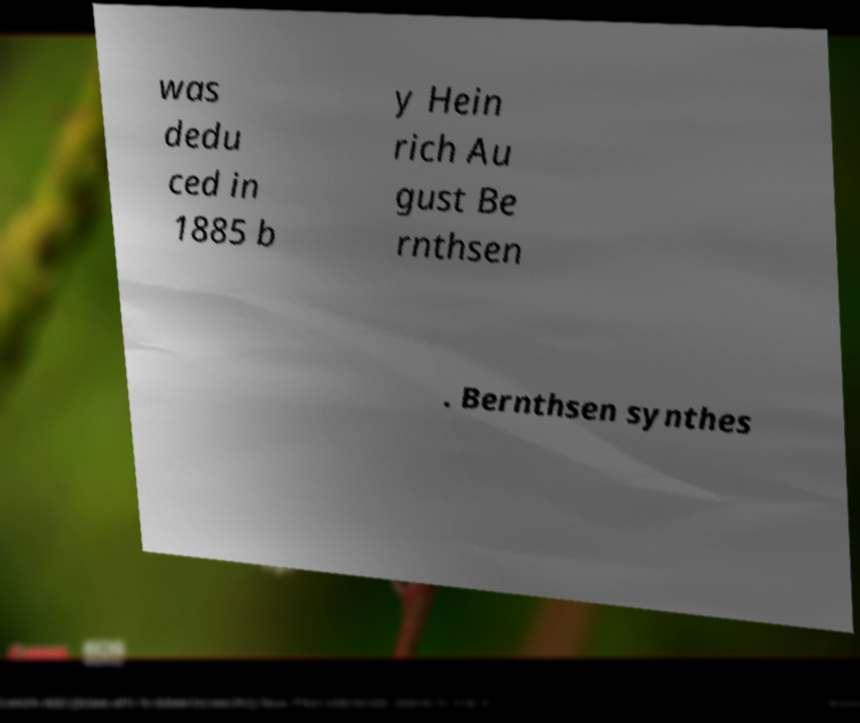Could you extract and type out the text from this image? was dedu ced in 1885 b y Hein rich Au gust Be rnthsen . Bernthsen synthes 